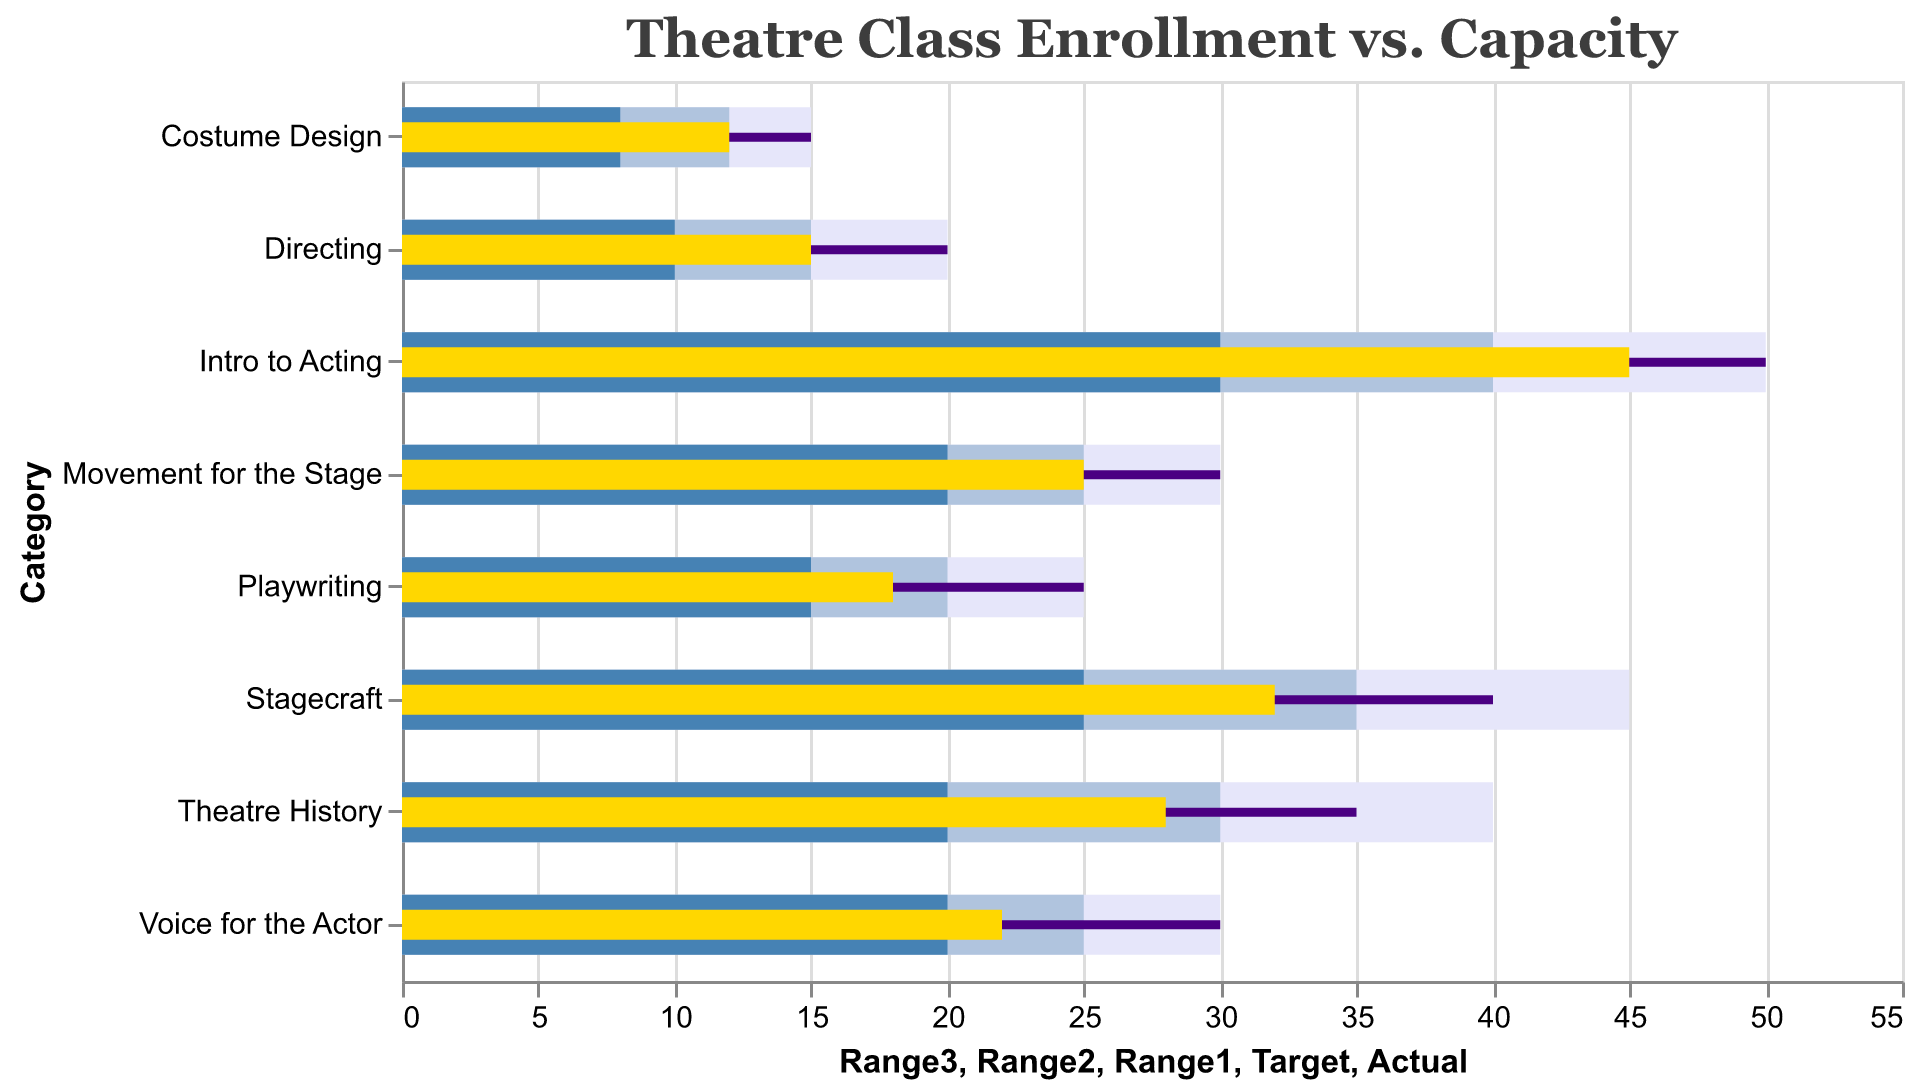What is the title of the chart? The chart title is given at the top and typically describes the main topic of the visualization. By looking at the top, we see it states "Theatre Class Enrollment vs. Capacity".
Answer: Theatre Class Enrollment vs. Capacity Which theatre class has the highest enrollment? To identify the class with the highest enrollment, look for the longest yellow bar in the chart. The longest yellow bar corresponds to "Intro to Acting" with 45 enrollments.
Answer: Intro to Acting What color is used to represent the target value for each category? The color representing the target value can be determined by identifying the thin bars indicating target values. These bars are dark purple.
Answer: Dark purple How many students are enrolled in the Directing class? To find the enrollment number for the Directing class, locate the yellow bar corresponding to "Directing", which indicates an enrollment of 15 students.
Answer: 15 What is the enrollment target for the Playwriting class? Locate the Playwriting bar, then find the dark purple thin bar indicating the target value, which is 25.
Answer: 25 Which class is closest to reaching its capacity? To determine which class is closest to reaching capacity, compare the lengths of the yellow bar (actual enrollment) to the dark purple bar (target). "Intro to Acting" with 45 students out of a 50 capacity (90%) is the closest.
Answer: Intro to Acting Which class has the largest gap between its current enrollment and the target enrollment? Calculate the difference between actual and target enrollments for each class. "Voice for the Actor" has 30 target minus 22 actual, giving a gap of 8, the largest difference among the classes.
Answer: Voice for the Actor What ranges do the colors represent in the chart? To identify what the colors represent, refer to range values in the data: Light lavender represents the entire range, light blue is the next level, sky blue is the closest to target values, and dark purple represents the target.
Answer: Range3: Light lavender, Range2: Light blue, Range1: Sky blue, Target: Dark purple By how many students does the Costume Design class lag behind its capacity? Subtract the actual enrollment from the target enrollment for Costume Design which is 15 - 12 = 3.
Answer: 3 What is the total enrollment across all listed classes? Sum the actual enrollments of all classes: 45 + 32 + 28 + 18 + 22 + 25 + 15 + 12 = 197.
Answer: 197 